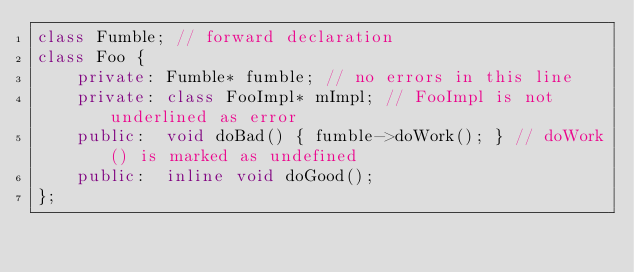Convert code to text. <code><loc_0><loc_0><loc_500><loc_500><_C++_>class Fumble; // forward declaration
class Foo {
    private: Fumble* fumble; // no errors in this line
    private: class FooImpl* mImpl; // FooImpl is not underlined as error
    public:  void doBad() { fumble->doWork(); } // doWork() is marked as undefined
    public:  inline void doGood();
};
</code> 